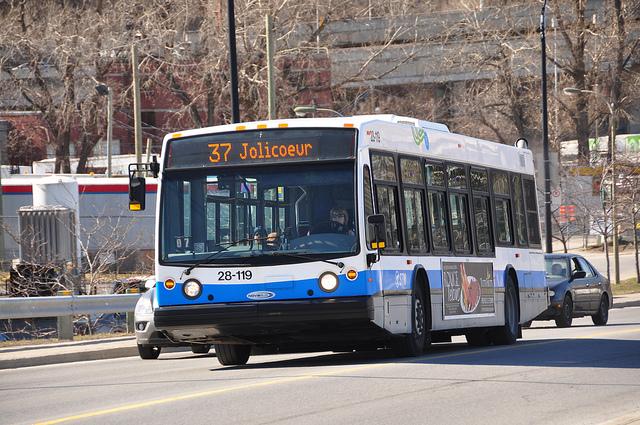What number is this bus?
Quick response, please. 37. What side is the driver on?
Quick response, please. Left. What is the bus' destination?
Give a very brief answer. Jolicoeur. 